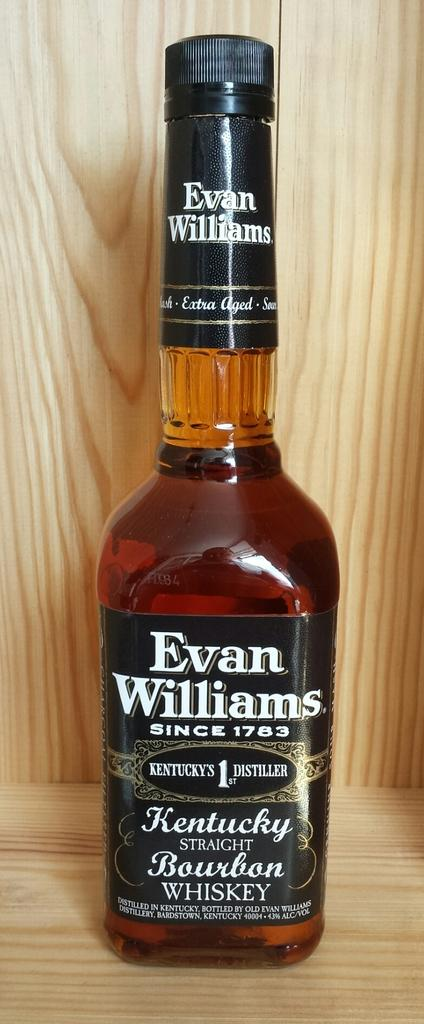<image>
Summarize the visual content of the image. a full bottle of liquor by Evan Williams for Kentucky Bourbon 